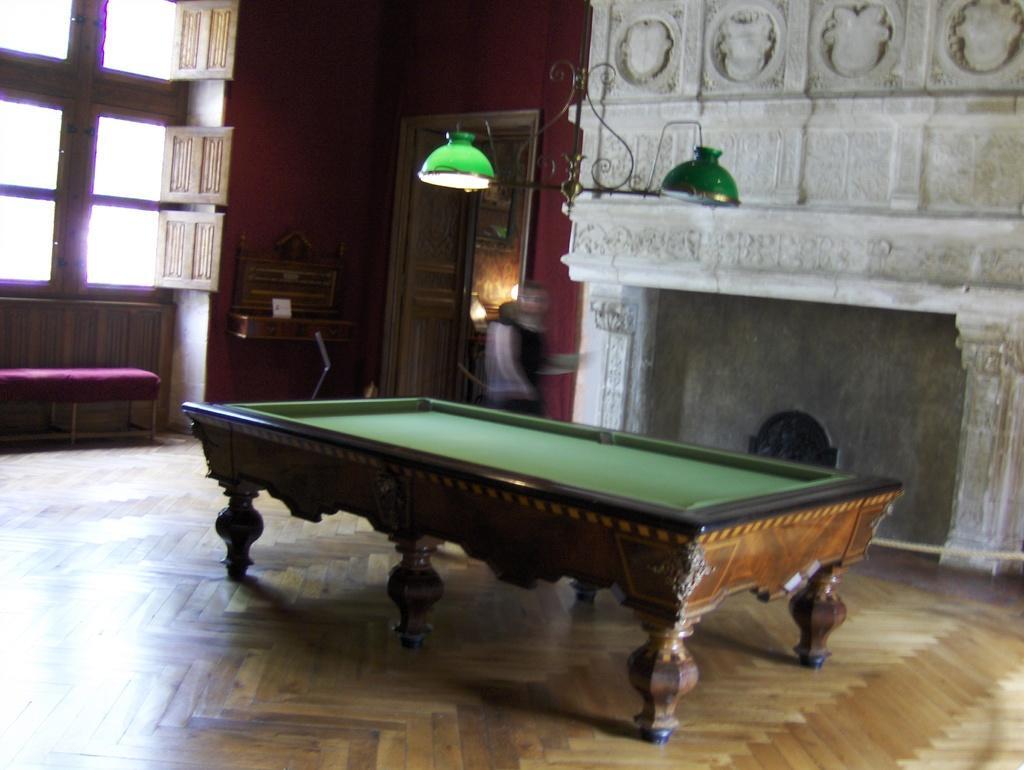Can you describe this image briefly? This image consists of Snooker Pool board, lights on the top, windows on the left. Lights are in green color. 